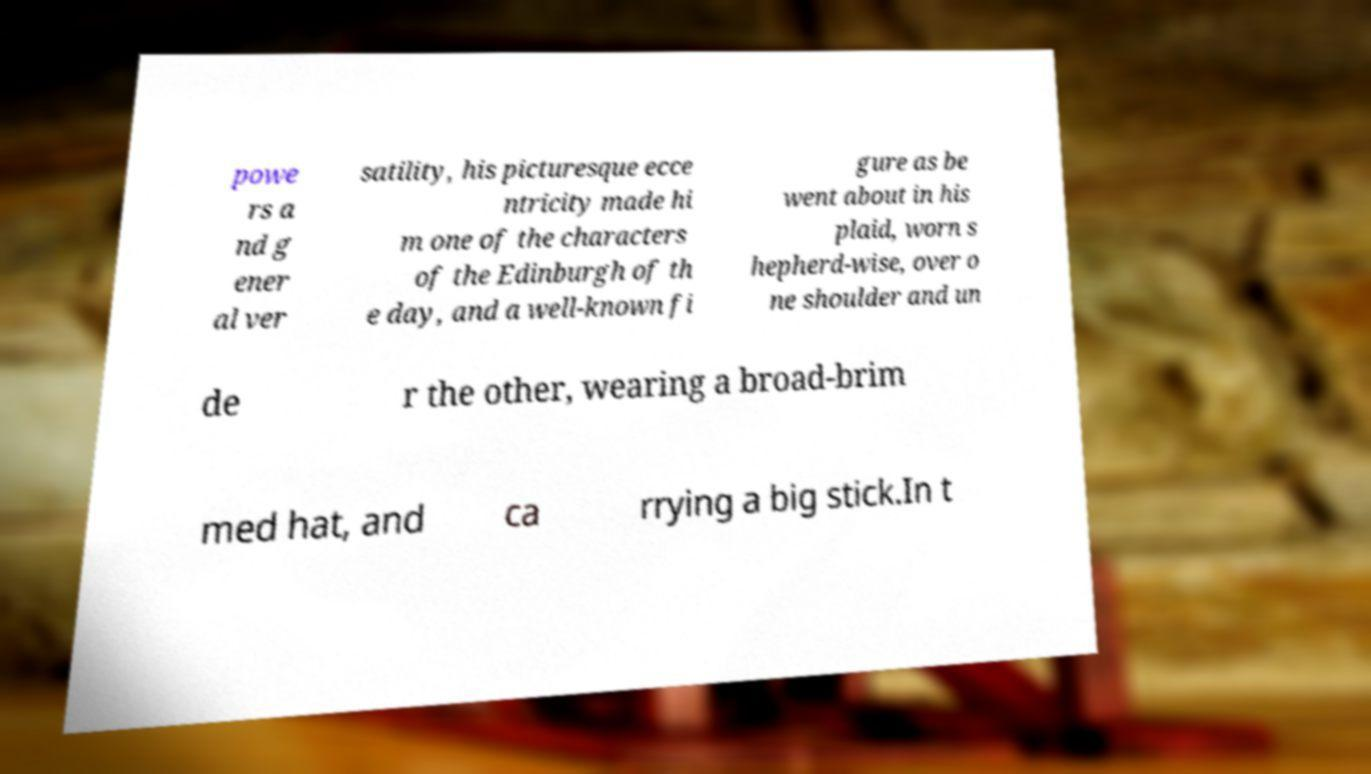Please identify and transcribe the text found in this image. powe rs a nd g ener al ver satility, his picturesque ecce ntricity made hi m one of the characters of the Edinburgh of th e day, and a well-known fi gure as be went about in his plaid, worn s hepherd-wise, over o ne shoulder and un de r the other, wearing a broad-brim med hat, and ca rrying a big stick.In t 